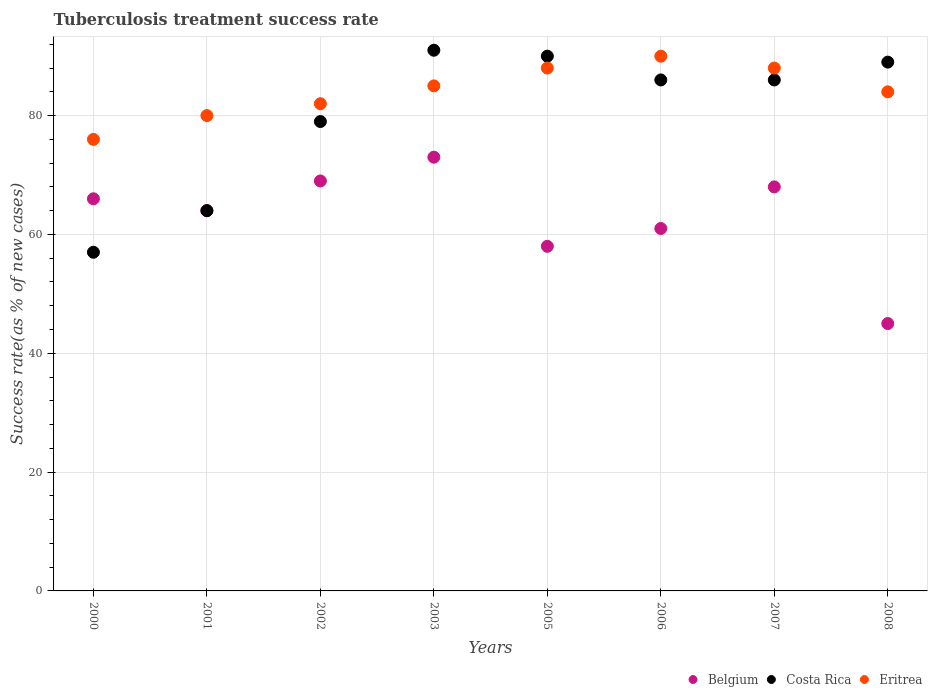Is the number of dotlines equal to the number of legend labels?
Offer a terse response. Yes. What is the tuberculosis treatment success rate in Costa Rica in 2003?
Give a very brief answer. 91. Across all years, what is the maximum tuberculosis treatment success rate in Costa Rica?
Provide a succinct answer. 91. Across all years, what is the minimum tuberculosis treatment success rate in Costa Rica?
Offer a very short reply. 57. What is the total tuberculosis treatment success rate in Belgium in the graph?
Offer a very short reply. 504. What is the average tuberculosis treatment success rate in Eritrea per year?
Give a very brief answer. 84.12. In the year 2003, what is the difference between the tuberculosis treatment success rate in Costa Rica and tuberculosis treatment success rate in Eritrea?
Provide a short and direct response. 6. What is the ratio of the tuberculosis treatment success rate in Costa Rica in 2000 to that in 2005?
Provide a short and direct response. 0.63. What is the difference between the highest and the lowest tuberculosis treatment success rate in Costa Rica?
Make the answer very short. 34. Is the sum of the tuberculosis treatment success rate in Costa Rica in 2000 and 2006 greater than the maximum tuberculosis treatment success rate in Belgium across all years?
Give a very brief answer. Yes. Is it the case that in every year, the sum of the tuberculosis treatment success rate in Costa Rica and tuberculosis treatment success rate in Belgium  is greater than the tuberculosis treatment success rate in Eritrea?
Offer a terse response. Yes. Does the tuberculosis treatment success rate in Eritrea monotonically increase over the years?
Give a very brief answer. No. Is the tuberculosis treatment success rate in Costa Rica strictly less than the tuberculosis treatment success rate in Eritrea over the years?
Give a very brief answer. No. Does the graph contain any zero values?
Provide a succinct answer. No. Does the graph contain grids?
Your answer should be compact. Yes. Where does the legend appear in the graph?
Provide a short and direct response. Bottom right. How many legend labels are there?
Provide a succinct answer. 3. How are the legend labels stacked?
Offer a terse response. Horizontal. What is the title of the graph?
Your answer should be compact. Tuberculosis treatment success rate. What is the label or title of the Y-axis?
Your answer should be compact. Success rate(as % of new cases). What is the Success rate(as % of new cases) of Belgium in 2000?
Provide a short and direct response. 66. What is the Success rate(as % of new cases) of Costa Rica in 2000?
Give a very brief answer. 57. What is the Success rate(as % of new cases) in Eritrea in 2000?
Ensure brevity in your answer.  76. What is the Success rate(as % of new cases) in Costa Rica in 2001?
Offer a very short reply. 64. What is the Success rate(as % of new cases) in Eritrea in 2001?
Provide a short and direct response. 80. What is the Success rate(as % of new cases) in Costa Rica in 2002?
Give a very brief answer. 79. What is the Success rate(as % of new cases) of Belgium in 2003?
Your answer should be compact. 73. What is the Success rate(as % of new cases) in Costa Rica in 2003?
Offer a terse response. 91. What is the Success rate(as % of new cases) in Eritrea in 2003?
Your answer should be very brief. 85. What is the Success rate(as % of new cases) of Costa Rica in 2005?
Give a very brief answer. 90. What is the Success rate(as % of new cases) in Eritrea in 2005?
Your answer should be very brief. 88. What is the Success rate(as % of new cases) in Costa Rica in 2006?
Provide a succinct answer. 86. What is the Success rate(as % of new cases) of Costa Rica in 2007?
Your answer should be compact. 86. What is the Success rate(as % of new cases) of Eritrea in 2007?
Your response must be concise. 88. What is the Success rate(as % of new cases) of Costa Rica in 2008?
Your answer should be compact. 89. What is the Success rate(as % of new cases) of Eritrea in 2008?
Offer a very short reply. 84. Across all years, what is the maximum Success rate(as % of new cases) of Costa Rica?
Keep it short and to the point. 91. Across all years, what is the maximum Success rate(as % of new cases) in Eritrea?
Offer a terse response. 90. Across all years, what is the minimum Success rate(as % of new cases) of Costa Rica?
Provide a short and direct response. 57. Across all years, what is the minimum Success rate(as % of new cases) of Eritrea?
Your answer should be very brief. 76. What is the total Success rate(as % of new cases) in Belgium in the graph?
Your answer should be compact. 504. What is the total Success rate(as % of new cases) in Costa Rica in the graph?
Provide a short and direct response. 642. What is the total Success rate(as % of new cases) of Eritrea in the graph?
Your answer should be very brief. 673. What is the difference between the Success rate(as % of new cases) of Belgium in 2000 and that in 2001?
Make the answer very short. 2. What is the difference between the Success rate(as % of new cases) in Eritrea in 2000 and that in 2001?
Offer a very short reply. -4. What is the difference between the Success rate(as % of new cases) in Belgium in 2000 and that in 2002?
Give a very brief answer. -3. What is the difference between the Success rate(as % of new cases) of Eritrea in 2000 and that in 2002?
Your answer should be compact. -6. What is the difference between the Success rate(as % of new cases) of Costa Rica in 2000 and that in 2003?
Provide a short and direct response. -34. What is the difference between the Success rate(as % of new cases) of Eritrea in 2000 and that in 2003?
Provide a short and direct response. -9. What is the difference between the Success rate(as % of new cases) of Costa Rica in 2000 and that in 2005?
Keep it short and to the point. -33. What is the difference between the Success rate(as % of new cases) in Belgium in 2000 and that in 2008?
Give a very brief answer. 21. What is the difference between the Success rate(as % of new cases) of Costa Rica in 2000 and that in 2008?
Your response must be concise. -32. What is the difference between the Success rate(as % of new cases) of Eritrea in 2001 and that in 2002?
Your answer should be very brief. -2. What is the difference between the Success rate(as % of new cases) in Belgium in 2001 and that in 2003?
Your response must be concise. -9. What is the difference between the Success rate(as % of new cases) in Costa Rica in 2001 and that in 2003?
Ensure brevity in your answer.  -27. What is the difference between the Success rate(as % of new cases) in Costa Rica in 2001 and that in 2007?
Your response must be concise. -22. What is the difference between the Success rate(as % of new cases) of Eritrea in 2001 and that in 2007?
Offer a very short reply. -8. What is the difference between the Success rate(as % of new cases) of Belgium in 2001 and that in 2008?
Your response must be concise. 19. What is the difference between the Success rate(as % of new cases) of Eritrea in 2001 and that in 2008?
Provide a succinct answer. -4. What is the difference between the Success rate(as % of new cases) in Belgium in 2002 and that in 2003?
Provide a short and direct response. -4. What is the difference between the Success rate(as % of new cases) in Belgium in 2002 and that in 2005?
Offer a terse response. 11. What is the difference between the Success rate(as % of new cases) in Costa Rica in 2002 and that in 2005?
Make the answer very short. -11. What is the difference between the Success rate(as % of new cases) of Eritrea in 2002 and that in 2005?
Provide a short and direct response. -6. What is the difference between the Success rate(as % of new cases) of Costa Rica in 2002 and that in 2006?
Offer a very short reply. -7. What is the difference between the Success rate(as % of new cases) of Eritrea in 2002 and that in 2006?
Your response must be concise. -8. What is the difference between the Success rate(as % of new cases) in Belgium in 2002 and that in 2007?
Your response must be concise. 1. What is the difference between the Success rate(as % of new cases) of Costa Rica in 2002 and that in 2007?
Your answer should be compact. -7. What is the difference between the Success rate(as % of new cases) in Belgium in 2003 and that in 2005?
Provide a short and direct response. 15. What is the difference between the Success rate(as % of new cases) of Belgium in 2003 and that in 2006?
Offer a very short reply. 12. What is the difference between the Success rate(as % of new cases) of Costa Rica in 2003 and that in 2006?
Your response must be concise. 5. What is the difference between the Success rate(as % of new cases) of Eritrea in 2003 and that in 2006?
Provide a succinct answer. -5. What is the difference between the Success rate(as % of new cases) in Costa Rica in 2003 and that in 2007?
Give a very brief answer. 5. What is the difference between the Success rate(as % of new cases) of Eritrea in 2003 and that in 2007?
Ensure brevity in your answer.  -3. What is the difference between the Success rate(as % of new cases) in Eritrea in 2005 and that in 2006?
Provide a succinct answer. -2. What is the difference between the Success rate(as % of new cases) of Costa Rica in 2005 and that in 2008?
Ensure brevity in your answer.  1. What is the difference between the Success rate(as % of new cases) in Eritrea in 2005 and that in 2008?
Offer a terse response. 4. What is the difference between the Success rate(as % of new cases) in Costa Rica in 2006 and that in 2007?
Give a very brief answer. 0. What is the difference between the Success rate(as % of new cases) in Belgium in 2000 and the Success rate(as % of new cases) in Eritrea in 2003?
Provide a short and direct response. -19. What is the difference between the Success rate(as % of new cases) of Costa Rica in 2000 and the Success rate(as % of new cases) of Eritrea in 2003?
Provide a succinct answer. -28. What is the difference between the Success rate(as % of new cases) in Belgium in 2000 and the Success rate(as % of new cases) in Eritrea in 2005?
Provide a short and direct response. -22. What is the difference between the Success rate(as % of new cases) in Costa Rica in 2000 and the Success rate(as % of new cases) in Eritrea in 2005?
Offer a very short reply. -31. What is the difference between the Success rate(as % of new cases) of Belgium in 2000 and the Success rate(as % of new cases) of Costa Rica in 2006?
Keep it short and to the point. -20. What is the difference between the Success rate(as % of new cases) in Belgium in 2000 and the Success rate(as % of new cases) in Eritrea in 2006?
Ensure brevity in your answer.  -24. What is the difference between the Success rate(as % of new cases) in Costa Rica in 2000 and the Success rate(as % of new cases) in Eritrea in 2006?
Ensure brevity in your answer.  -33. What is the difference between the Success rate(as % of new cases) in Costa Rica in 2000 and the Success rate(as % of new cases) in Eritrea in 2007?
Keep it short and to the point. -31. What is the difference between the Success rate(as % of new cases) in Belgium in 2000 and the Success rate(as % of new cases) in Eritrea in 2008?
Provide a short and direct response. -18. What is the difference between the Success rate(as % of new cases) in Costa Rica in 2000 and the Success rate(as % of new cases) in Eritrea in 2008?
Your response must be concise. -27. What is the difference between the Success rate(as % of new cases) in Belgium in 2001 and the Success rate(as % of new cases) in Eritrea in 2002?
Keep it short and to the point. -18. What is the difference between the Success rate(as % of new cases) of Costa Rica in 2001 and the Success rate(as % of new cases) of Eritrea in 2003?
Provide a short and direct response. -21. What is the difference between the Success rate(as % of new cases) of Belgium in 2001 and the Success rate(as % of new cases) of Costa Rica in 2005?
Provide a succinct answer. -26. What is the difference between the Success rate(as % of new cases) in Belgium in 2001 and the Success rate(as % of new cases) in Eritrea in 2005?
Your answer should be compact. -24. What is the difference between the Success rate(as % of new cases) of Costa Rica in 2001 and the Success rate(as % of new cases) of Eritrea in 2005?
Provide a succinct answer. -24. What is the difference between the Success rate(as % of new cases) in Belgium in 2001 and the Success rate(as % of new cases) in Costa Rica in 2006?
Keep it short and to the point. -22. What is the difference between the Success rate(as % of new cases) of Costa Rica in 2001 and the Success rate(as % of new cases) of Eritrea in 2006?
Ensure brevity in your answer.  -26. What is the difference between the Success rate(as % of new cases) of Belgium in 2001 and the Success rate(as % of new cases) of Eritrea in 2007?
Ensure brevity in your answer.  -24. What is the difference between the Success rate(as % of new cases) in Costa Rica in 2001 and the Success rate(as % of new cases) in Eritrea in 2007?
Provide a short and direct response. -24. What is the difference between the Success rate(as % of new cases) of Belgium in 2001 and the Success rate(as % of new cases) of Costa Rica in 2008?
Your answer should be compact. -25. What is the difference between the Success rate(as % of new cases) of Belgium in 2001 and the Success rate(as % of new cases) of Eritrea in 2008?
Provide a short and direct response. -20. What is the difference between the Success rate(as % of new cases) of Belgium in 2002 and the Success rate(as % of new cases) of Eritrea in 2006?
Ensure brevity in your answer.  -21. What is the difference between the Success rate(as % of new cases) of Costa Rica in 2002 and the Success rate(as % of new cases) of Eritrea in 2006?
Your answer should be very brief. -11. What is the difference between the Success rate(as % of new cases) in Belgium in 2002 and the Success rate(as % of new cases) in Eritrea in 2007?
Provide a succinct answer. -19. What is the difference between the Success rate(as % of new cases) in Costa Rica in 2002 and the Success rate(as % of new cases) in Eritrea in 2007?
Offer a terse response. -9. What is the difference between the Success rate(as % of new cases) in Belgium in 2002 and the Success rate(as % of new cases) in Eritrea in 2008?
Make the answer very short. -15. What is the difference between the Success rate(as % of new cases) of Belgium in 2003 and the Success rate(as % of new cases) of Eritrea in 2005?
Provide a short and direct response. -15. What is the difference between the Success rate(as % of new cases) of Costa Rica in 2003 and the Success rate(as % of new cases) of Eritrea in 2005?
Your answer should be compact. 3. What is the difference between the Success rate(as % of new cases) of Belgium in 2003 and the Success rate(as % of new cases) of Costa Rica in 2006?
Provide a short and direct response. -13. What is the difference between the Success rate(as % of new cases) in Belgium in 2003 and the Success rate(as % of new cases) in Eritrea in 2006?
Keep it short and to the point. -17. What is the difference between the Success rate(as % of new cases) of Costa Rica in 2003 and the Success rate(as % of new cases) of Eritrea in 2006?
Ensure brevity in your answer.  1. What is the difference between the Success rate(as % of new cases) in Belgium in 2003 and the Success rate(as % of new cases) in Costa Rica in 2007?
Offer a terse response. -13. What is the difference between the Success rate(as % of new cases) of Belgium in 2003 and the Success rate(as % of new cases) of Eritrea in 2007?
Keep it short and to the point. -15. What is the difference between the Success rate(as % of new cases) of Belgium in 2003 and the Success rate(as % of new cases) of Costa Rica in 2008?
Your answer should be compact. -16. What is the difference between the Success rate(as % of new cases) in Belgium in 2003 and the Success rate(as % of new cases) in Eritrea in 2008?
Your answer should be very brief. -11. What is the difference between the Success rate(as % of new cases) of Belgium in 2005 and the Success rate(as % of new cases) of Eritrea in 2006?
Offer a very short reply. -32. What is the difference between the Success rate(as % of new cases) of Costa Rica in 2005 and the Success rate(as % of new cases) of Eritrea in 2006?
Provide a succinct answer. 0. What is the difference between the Success rate(as % of new cases) in Belgium in 2005 and the Success rate(as % of new cases) in Costa Rica in 2008?
Offer a very short reply. -31. What is the difference between the Success rate(as % of new cases) of Belgium in 2005 and the Success rate(as % of new cases) of Eritrea in 2008?
Your answer should be very brief. -26. What is the difference between the Success rate(as % of new cases) of Costa Rica in 2005 and the Success rate(as % of new cases) of Eritrea in 2008?
Offer a terse response. 6. What is the difference between the Success rate(as % of new cases) in Belgium in 2006 and the Success rate(as % of new cases) in Costa Rica in 2007?
Your response must be concise. -25. What is the difference between the Success rate(as % of new cases) in Belgium in 2006 and the Success rate(as % of new cases) in Eritrea in 2007?
Make the answer very short. -27. What is the difference between the Success rate(as % of new cases) of Costa Rica in 2006 and the Success rate(as % of new cases) of Eritrea in 2007?
Ensure brevity in your answer.  -2. What is the difference between the Success rate(as % of new cases) of Belgium in 2006 and the Success rate(as % of new cases) of Eritrea in 2008?
Ensure brevity in your answer.  -23. What is the difference between the Success rate(as % of new cases) in Costa Rica in 2007 and the Success rate(as % of new cases) in Eritrea in 2008?
Your answer should be very brief. 2. What is the average Success rate(as % of new cases) in Belgium per year?
Ensure brevity in your answer.  63. What is the average Success rate(as % of new cases) in Costa Rica per year?
Your answer should be compact. 80.25. What is the average Success rate(as % of new cases) in Eritrea per year?
Give a very brief answer. 84.12. In the year 2000, what is the difference between the Success rate(as % of new cases) in Belgium and Success rate(as % of new cases) in Costa Rica?
Offer a terse response. 9. In the year 2000, what is the difference between the Success rate(as % of new cases) in Costa Rica and Success rate(as % of new cases) in Eritrea?
Your answer should be compact. -19. In the year 2001, what is the difference between the Success rate(as % of new cases) of Belgium and Success rate(as % of new cases) of Costa Rica?
Provide a short and direct response. 0. In the year 2001, what is the difference between the Success rate(as % of new cases) of Costa Rica and Success rate(as % of new cases) of Eritrea?
Offer a terse response. -16. In the year 2002, what is the difference between the Success rate(as % of new cases) in Belgium and Success rate(as % of new cases) in Costa Rica?
Keep it short and to the point. -10. In the year 2005, what is the difference between the Success rate(as % of new cases) of Belgium and Success rate(as % of new cases) of Costa Rica?
Offer a terse response. -32. In the year 2006, what is the difference between the Success rate(as % of new cases) of Belgium and Success rate(as % of new cases) of Costa Rica?
Offer a terse response. -25. In the year 2006, what is the difference between the Success rate(as % of new cases) in Costa Rica and Success rate(as % of new cases) in Eritrea?
Your answer should be very brief. -4. In the year 2008, what is the difference between the Success rate(as % of new cases) of Belgium and Success rate(as % of new cases) of Costa Rica?
Offer a very short reply. -44. In the year 2008, what is the difference between the Success rate(as % of new cases) in Belgium and Success rate(as % of new cases) in Eritrea?
Provide a short and direct response. -39. In the year 2008, what is the difference between the Success rate(as % of new cases) in Costa Rica and Success rate(as % of new cases) in Eritrea?
Make the answer very short. 5. What is the ratio of the Success rate(as % of new cases) of Belgium in 2000 to that in 2001?
Offer a very short reply. 1.03. What is the ratio of the Success rate(as % of new cases) of Costa Rica in 2000 to that in 2001?
Your answer should be compact. 0.89. What is the ratio of the Success rate(as % of new cases) of Belgium in 2000 to that in 2002?
Offer a very short reply. 0.96. What is the ratio of the Success rate(as % of new cases) in Costa Rica in 2000 to that in 2002?
Provide a succinct answer. 0.72. What is the ratio of the Success rate(as % of new cases) of Eritrea in 2000 to that in 2002?
Offer a very short reply. 0.93. What is the ratio of the Success rate(as % of new cases) of Belgium in 2000 to that in 2003?
Offer a terse response. 0.9. What is the ratio of the Success rate(as % of new cases) of Costa Rica in 2000 to that in 2003?
Offer a terse response. 0.63. What is the ratio of the Success rate(as % of new cases) of Eritrea in 2000 to that in 2003?
Keep it short and to the point. 0.89. What is the ratio of the Success rate(as % of new cases) of Belgium in 2000 to that in 2005?
Your answer should be compact. 1.14. What is the ratio of the Success rate(as % of new cases) in Costa Rica in 2000 to that in 2005?
Provide a short and direct response. 0.63. What is the ratio of the Success rate(as % of new cases) in Eritrea in 2000 to that in 2005?
Make the answer very short. 0.86. What is the ratio of the Success rate(as % of new cases) of Belgium in 2000 to that in 2006?
Offer a terse response. 1.08. What is the ratio of the Success rate(as % of new cases) in Costa Rica in 2000 to that in 2006?
Your answer should be compact. 0.66. What is the ratio of the Success rate(as % of new cases) in Eritrea in 2000 to that in 2006?
Keep it short and to the point. 0.84. What is the ratio of the Success rate(as % of new cases) of Belgium in 2000 to that in 2007?
Make the answer very short. 0.97. What is the ratio of the Success rate(as % of new cases) of Costa Rica in 2000 to that in 2007?
Offer a very short reply. 0.66. What is the ratio of the Success rate(as % of new cases) of Eritrea in 2000 to that in 2007?
Provide a succinct answer. 0.86. What is the ratio of the Success rate(as % of new cases) of Belgium in 2000 to that in 2008?
Your response must be concise. 1.47. What is the ratio of the Success rate(as % of new cases) in Costa Rica in 2000 to that in 2008?
Offer a very short reply. 0.64. What is the ratio of the Success rate(as % of new cases) of Eritrea in 2000 to that in 2008?
Ensure brevity in your answer.  0.9. What is the ratio of the Success rate(as % of new cases) of Belgium in 2001 to that in 2002?
Ensure brevity in your answer.  0.93. What is the ratio of the Success rate(as % of new cases) in Costa Rica in 2001 to that in 2002?
Offer a terse response. 0.81. What is the ratio of the Success rate(as % of new cases) of Eritrea in 2001 to that in 2002?
Ensure brevity in your answer.  0.98. What is the ratio of the Success rate(as % of new cases) in Belgium in 2001 to that in 2003?
Your answer should be compact. 0.88. What is the ratio of the Success rate(as % of new cases) of Costa Rica in 2001 to that in 2003?
Give a very brief answer. 0.7. What is the ratio of the Success rate(as % of new cases) in Belgium in 2001 to that in 2005?
Offer a very short reply. 1.1. What is the ratio of the Success rate(as % of new cases) of Costa Rica in 2001 to that in 2005?
Your response must be concise. 0.71. What is the ratio of the Success rate(as % of new cases) of Belgium in 2001 to that in 2006?
Your response must be concise. 1.05. What is the ratio of the Success rate(as % of new cases) of Costa Rica in 2001 to that in 2006?
Offer a terse response. 0.74. What is the ratio of the Success rate(as % of new cases) of Belgium in 2001 to that in 2007?
Provide a short and direct response. 0.94. What is the ratio of the Success rate(as % of new cases) of Costa Rica in 2001 to that in 2007?
Offer a terse response. 0.74. What is the ratio of the Success rate(as % of new cases) in Eritrea in 2001 to that in 2007?
Offer a very short reply. 0.91. What is the ratio of the Success rate(as % of new cases) in Belgium in 2001 to that in 2008?
Provide a succinct answer. 1.42. What is the ratio of the Success rate(as % of new cases) of Costa Rica in 2001 to that in 2008?
Provide a succinct answer. 0.72. What is the ratio of the Success rate(as % of new cases) of Belgium in 2002 to that in 2003?
Provide a succinct answer. 0.95. What is the ratio of the Success rate(as % of new cases) of Costa Rica in 2002 to that in 2003?
Your answer should be compact. 0.87. What is the ratio of the Success rate(as % of new cases) of Eritrea in 2002 to that in 2003?
Ensure brevity in your answer.  0.96. What is the ratio of the Success rate(as % of new cases) of Belgium in 2002 to that in 2005?
Offer a terse response. 1.19. What is the ratio of the Success rate(as % of new cases) in Costa Rica in 2002 to that in 2005?
Offer a terse response. 0.88. What is the ratio of the Success rate(as % of new cases) of Eritrea in 2002 to that in 2005?
Make the answer very short. 0.93. What is the ratio of the Success rate(as % of new cases) of Belgium in 2002 to that in 2006?
Offer a terse response. 1.13. What is the ratio of the Success rate(as % of new cases) in Costa Rica in 2002 to that in 2006?
Provide a succinct answer. 0.92. What is the ratio of the Success rate(as % of new cases) in Eritrea in 2002 to that in 2006?
Provide a short and direct response. 0.91. What is the ratio of the Success rate(as % of new cases) of Belgium in 2002 to that in 2007?
Your answer should be compact. 1.01. What is the ratio of the Success rate(as % of new cases) in Costa Rica in 2002 to that in 2007?
Your answer should be compact. 0.92. What is the ratio of the Success rate(as % of new cases) of Eritrea in 2002 to that in 2007?
Make the answer very short. 0.93. What is the ratio of the Success rate(as % of new cases) in Belgium in 2002 to that in 2008?
Provide a short and direct response. 1.53. What is the ratio of the Success rate(as % of new cases) of Costa Rica in 2002 to that in 2008?
Your answer should be compact. 0.89. What is the ratio of the Success rate(as % of new cases) in Eritrea in 2002 to that in 2008?
Ensure brevity in your answer.  0.98. What is the ratio of the Success rate(as % of new cases) in Belgium in 2003 to that in 2005?
Make the answer very short. 1.26. What is the ratio of the Success rate(as % of new cases) in Costa Rica in 2003 to that in 2005?
Make the answer very short. 1.01. What is the ratio of the Success rate(as % of new cases) in Eritrea in 2003 to that in 2005?
Offer a terse response. 0.97. What is the ratio of the Success rate(as % of new cases) in Belgium in 2003 to that in 2006?
Your answer should be very brief. 1.2. What is the ratio of the Success rate(as % of new cases) in Costa Rica in 2003 to that in 2006?
Keep it short and to the point. 1.06. What is the ratio of the Success rate(as % of new cases) in Eritrea in 2003 to that in 2006?
Ensure brevity in your answer.  0.94. What is the ratio of the Success rate(as % of new cases) in Belgium in 2003 to that in 2007?
Ensure brevity in your answer.  1.07. What is the ratio of the Success rate(as % of new cases) in Costa Rica in 2003 to that in 2007?
Ensure brevity in your answer.  1.06. What is the ratio of the Success rate(as % of new cases) in Eritrea in 2003 to that in 2007?
Provide a succinct answer. 0.97. What is the ratio of the Success rate(as % of new cases) of Belgium in 2003 to that in 2008?
Make the answer very short. 1.62. What is the ratio of the Success rate(as % of new cases) in Costa Rica in 2003 to that in 2008?
Keep it short and to the point. 1.02. What is the ratio of the Success rate(as % of new cases) in Eritrea in 2003 to that in 2008?
Provide a succinct answer. 1.01. What is the ratio of the Success rate(as % of new cases) of Belgium in 2005 to that in 2006?
Make the answer very short. 0.95. What is the ratio of the Success rate(as % of new cases) in Costa Rica in 2005 to that in 2006?
Offer a very short reply. 1.05. What is the ratio of the Success rate(as % of new cases) in Eritrea in 2005 to that in 2006?
Keep it short and to the point. 0.98. What is the ratio of the Success rate(as % of new cases) of Belgium in 2005 to that in 2007?
Keep it short and to the point. 0.85. What is the ratio of the Success rate(as % of new cases) of Costa Rica in 2005 to that in 2007?
Provide a short and direct response. 1.05. What is the ratio of the Success rate(as % of new cases) of Belgium in 2005 to that in 2008?
Offer a very short reply. 1.29. What is the ratio of the Success rate(as % of new cases) of Costa Rica in 2005 to that in 2008?
Keep it short and to the point. 1.01. What is the ratio of the Success rate(as % of new cases) in Eritrea in 2005 to that in 2008?
Your answer should be compact. 1.05. What is the ratio of the Success rate(as % of new cases) of Belgium in 2006 to that in 2007?
Keep it short and to the point. 0.9. What is the ratio of the Success rate(as % of new cases) in Costa Rica in 2006 to that in 2007?
Ensure brevity in your answer.  1. What is the ratio of the Success rate(as % of new cases) in Eritrea in 2006 to that in 2007?
Offer a terse response. 1.02. What is the ratio of the Success rate(as % of new cases) of Belgium in 2006 to that in 2008?
Give a very brief answer. 1.36. What is the ratio of the Success rate(as % of new cases) in Costa Rica in 2006 to that in 2008?
Make the answer very short. 0.97. What is the ratio of the Success rate(as % of new cases) in Eritrea in 2006 to that in 2008?
Offer a very short reply. 1.07. What is the ratio of the Success rate(as % of new cases) of Belgium in 2007 to that in 2008?
Make the answer very short. 1.51. What is the ratio of the Success rate(as % of new cases) in Costa Rica in 2007 to that in 2008?
Offer a very short reply. 0.97. What is the ratio of the Success rate(as % of new cases) in Eritrea in 2007 to that in 2008?
Keep it short and to the point. 1.05. What is the difference between the highest and the second highest Success rate(as % of new cases) in Belgium?
Keep it short and to the point. 4. What is the difference between the highest and the lowest Success rate(as % of new cases) in Belgium?
Keep it short and to the point. 28. What is the difference between the highest and the lowest Success rate(as % of new cases) of Eritrea?
Your answer should be compact. 14. 